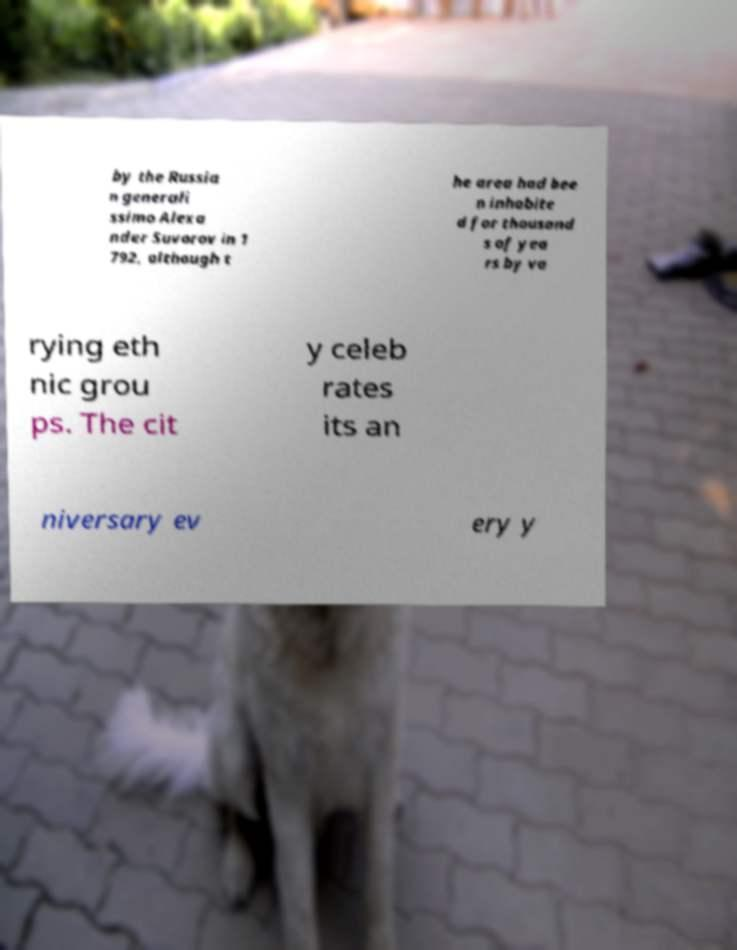Can you accurately transcribe the text from the provided image for me? by the Russia n generali ssimo Alexa nder Suvorov in 1 792, although t he area had bee n inhabite d for thousand s of yea rs by va rying eth nic grou ps. The cit y celeb rates its an niversary ev ery y 